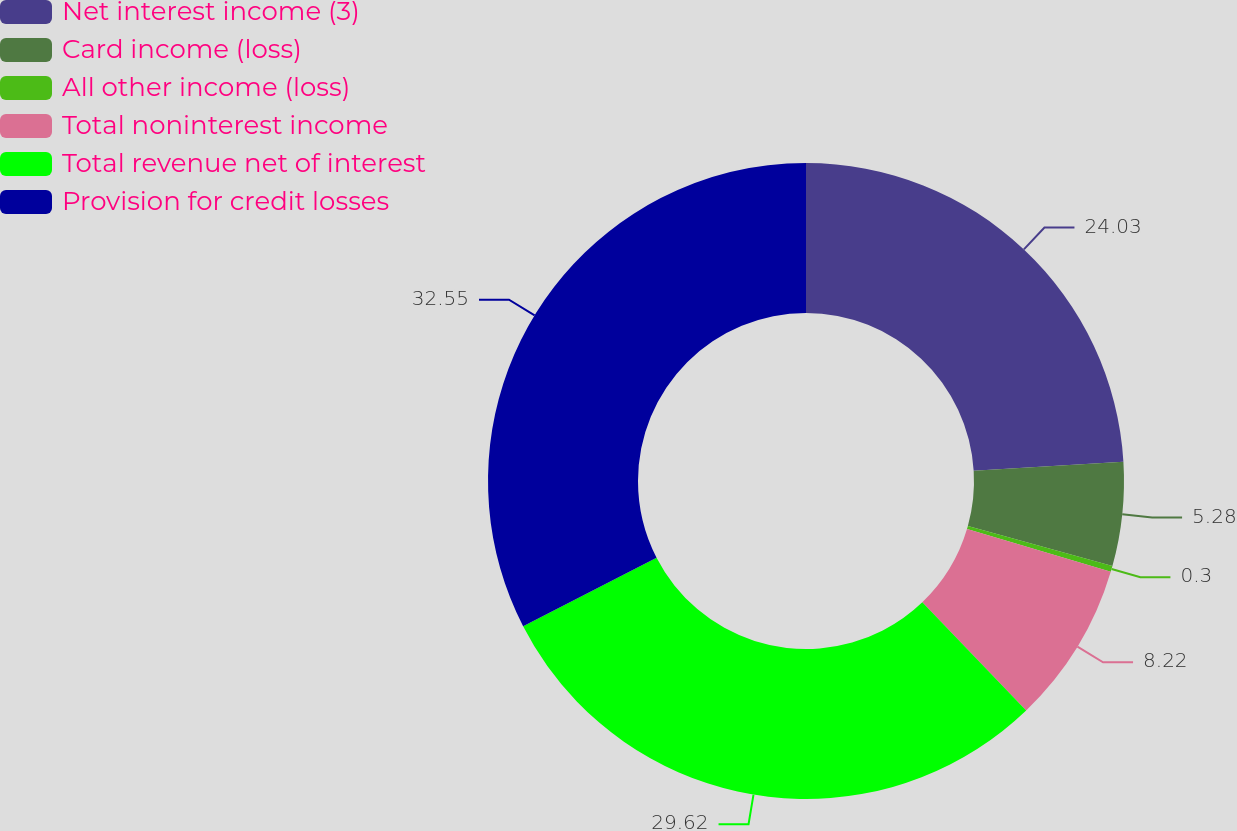<chart> <loc_0><loc_0><loc_500><loc_500><pie_chart><fcel>Net interest income (3)<fcel>Card income (loss)<fcel>All other income (loss)<fcel>Total noninterest income<fcel>Total revenue net of interest<fcel>Provision for credit losses<nl><fcel>24.03%<fcel>5.28%<fcel>0.3%<fcel>8.22%<fcel>29.62%<fcel>32.55%<nl></chart> 